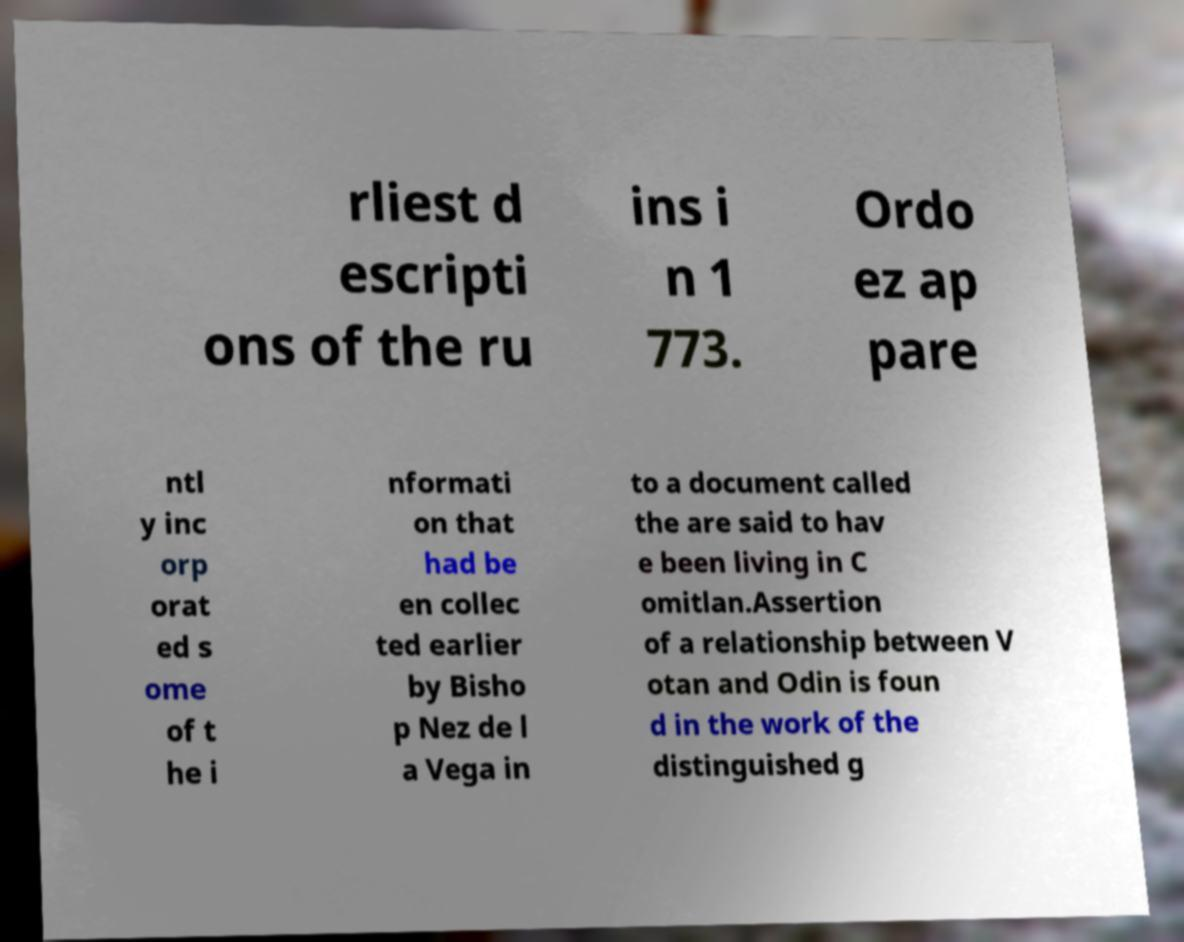Can you read and provide the text displayed in the image?This photo seems to have some interesting text. Can you extract and type it out for me? rliest d escripti ons of the ru ins i n 1 773. Ordo ez ap pare ntl y inc orp orat ed s ome of t he i nformati on that had be en collec ted earlier by Bisho p Nez de l a Vega in to a document called the are said to hav e been living in C omitlan.Assertion of a relationship between V otan and Odin is foun d in the work of the distinguished g 